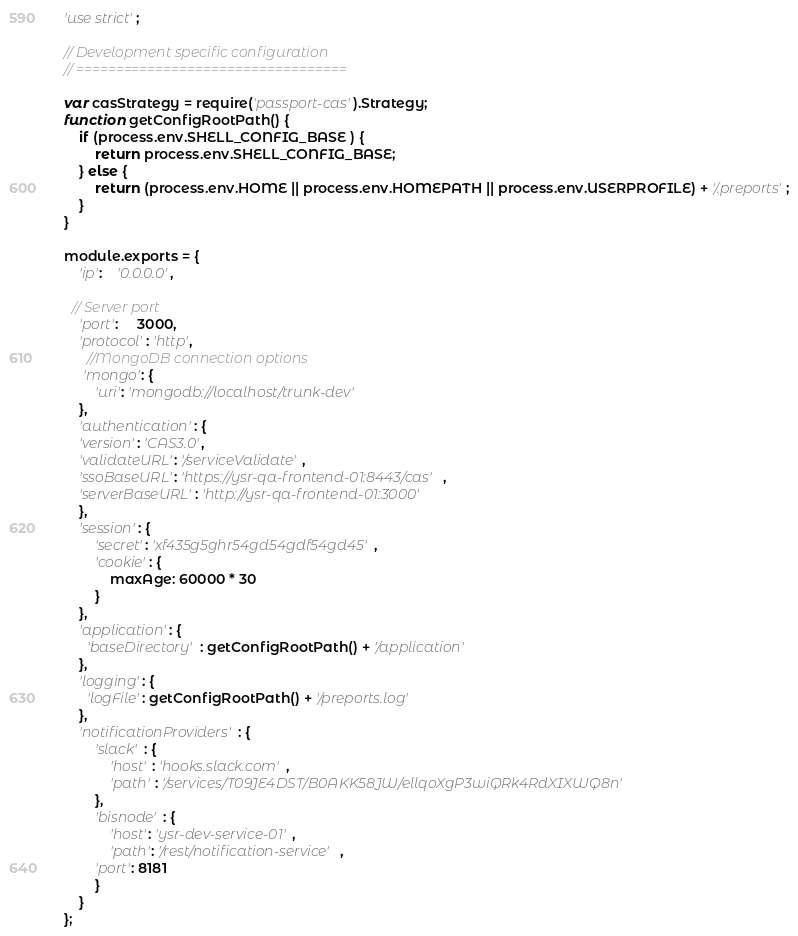Convert code to text. <code><loc_0><loc_0><loc_500><loc_500><_JavaScript_>'use strict';

// Development specific configuration
// ==================================

var casStrategy = require('passport-cas').Strategy;
function getConfigRootPath() {
	if (process.env.SHELL_CONFIG_BASE ) {
		return process.env.SHELL_CONFIG_BASE;
	} else {
		return (process.env.HOME || process.env.HOMEPATH || process.env.USERPROFILE) + '/.preports';
	}
}

module.exports = {
	'ip':    '0.0.0.0',

  // Server port
  	'port':     3000,
  	'protocol': 'http',
	  //MongoDB connection options
	 'mongo': {
	    'uri': 'mongodb://localhost/trunk-dev'
	},
	'authentication': {
    'version': 'CAS3.0',
    'validateURL': '/serviceValidate',
    'ssoBaseURL': 'https://ysr-qa-frontend-01:8443/cas',
    'serverBaseURL': 'http://ysr-qa-frontend-01:3000'	    
	},
	'session': {
        'secret': 'xf435g5ghr54gd54gdf54gd45',
        'cookie': {
            maxAge: 60000 * 30
        }
    },
	'application': {
      'baseDirectory' : getConfigRootPath() + '/application'
    },
    'logging': {
      'logFile': getConfigRootPath() + '/preports.log'
    },
    'notificationProviders': {
    	'slack' : {
    		'host' : 'hooks.slack.com',
    		'path' : '/services/T09JE4DST/B0AKK58JW/ellqoXgP3wiQRk4RdXIXWQ8n'
    	},
    	'bisnode' : {
    		'host': 'ysr-dev-service-01',
    		'path': '/rest/notification-service',
        'port': 8181
    	}
    }
};
</code> 